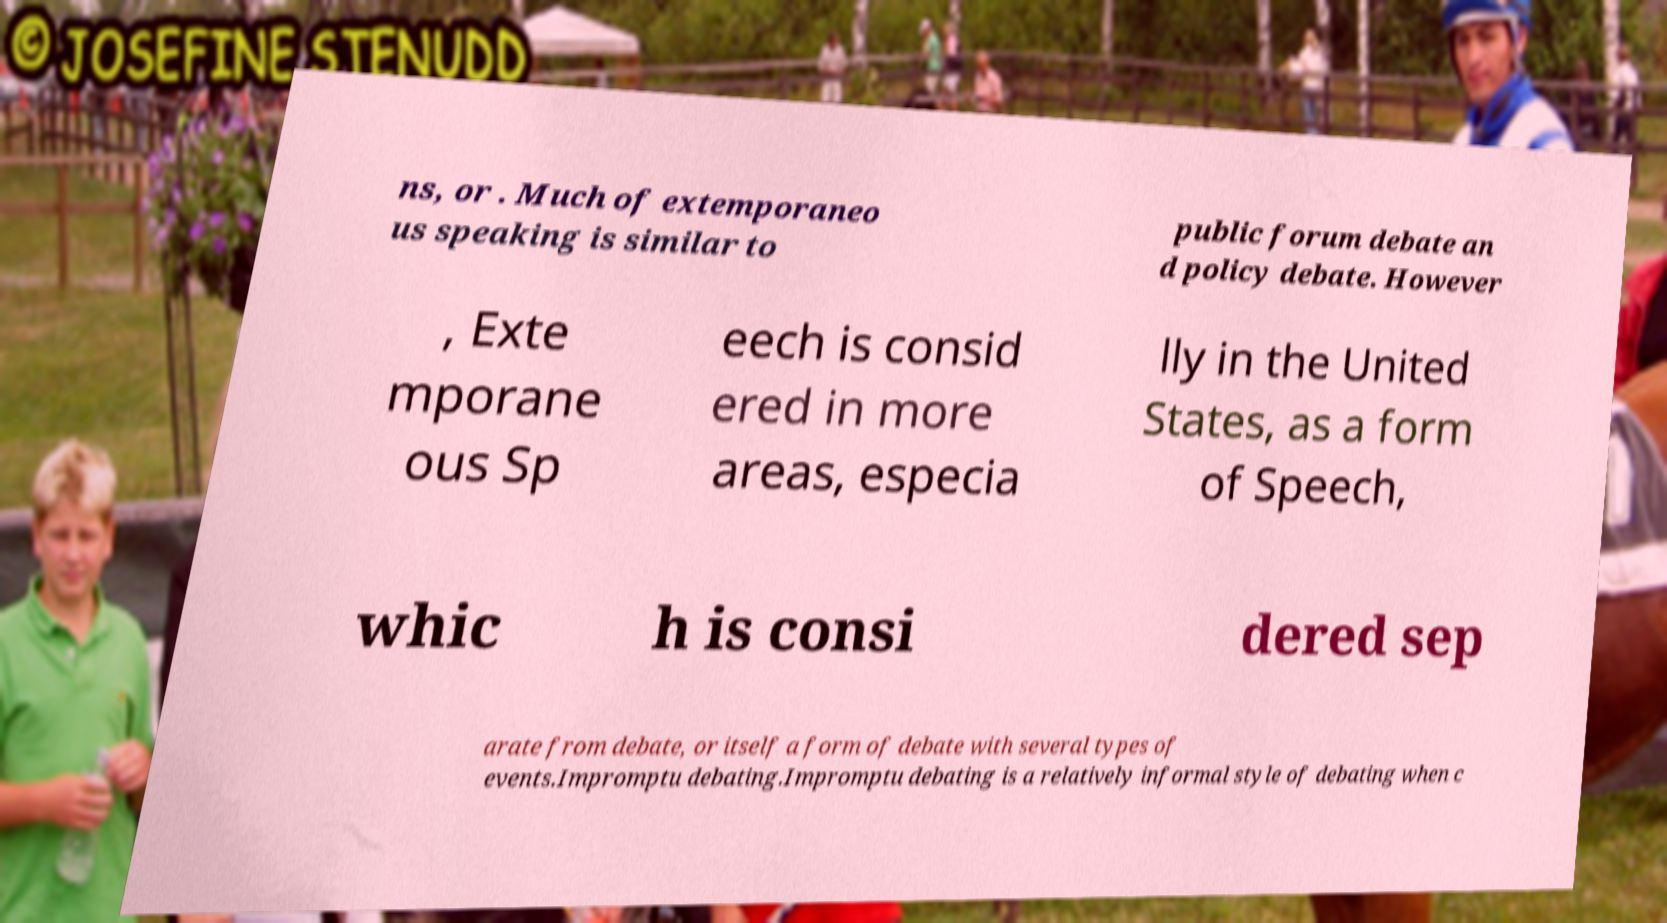What messages or text are displayed in this image? I need them in a readable, typed format. ns, or . Much of extemporaneo us speaking is similar to public forum debate an d policy debate. However , Exte mporane ous Sp eech is consid ered in more areas, especia lly in the United States, as a form of Speech, whic h is consi dered sep arate from debate, or itself a form of debate with several types of events.Impromptu debating.Impromptu debating is a relatively informal style of debating when c 